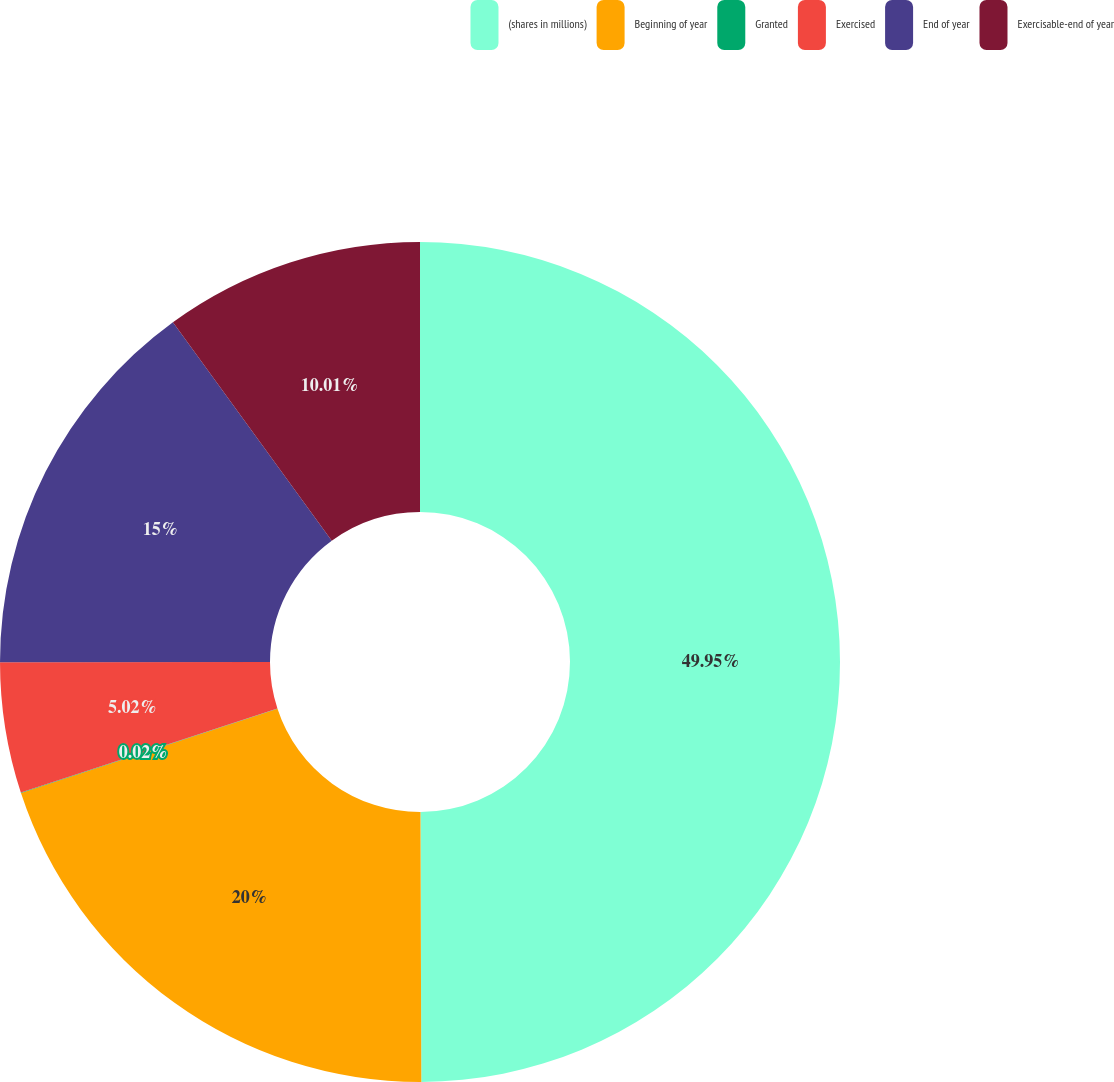<chart> <loc_0><loc_0><loc_500><loc_500><pie_chart><fcel>(shares in millions)<fcel>Beginning of year<fcel>Granted<fcel>Exercised<fcel>End of year<fcel>Exercisable-end of year<nl><fcel>49.95%<fcel>20.0%<fcel>0.02%<fcel>5.02%<fcel>15.0%<fcel>10.01%<nl></chart> 